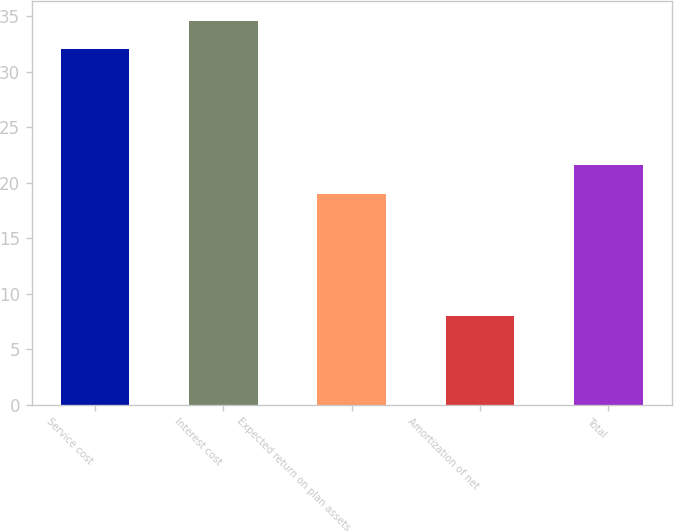Convert chart. <chart><loc_0><loc_0><loc_500><loc_500><bar_chart><fcel>Service cost<fcel>Interest cost<fcel>Expected return on plan assets<fcel>Amortization of net<fcel>Total<nl><fcel>32<fcel>34.6<fcel>19<fcel>8<fcel>21.6<nl></chart> 